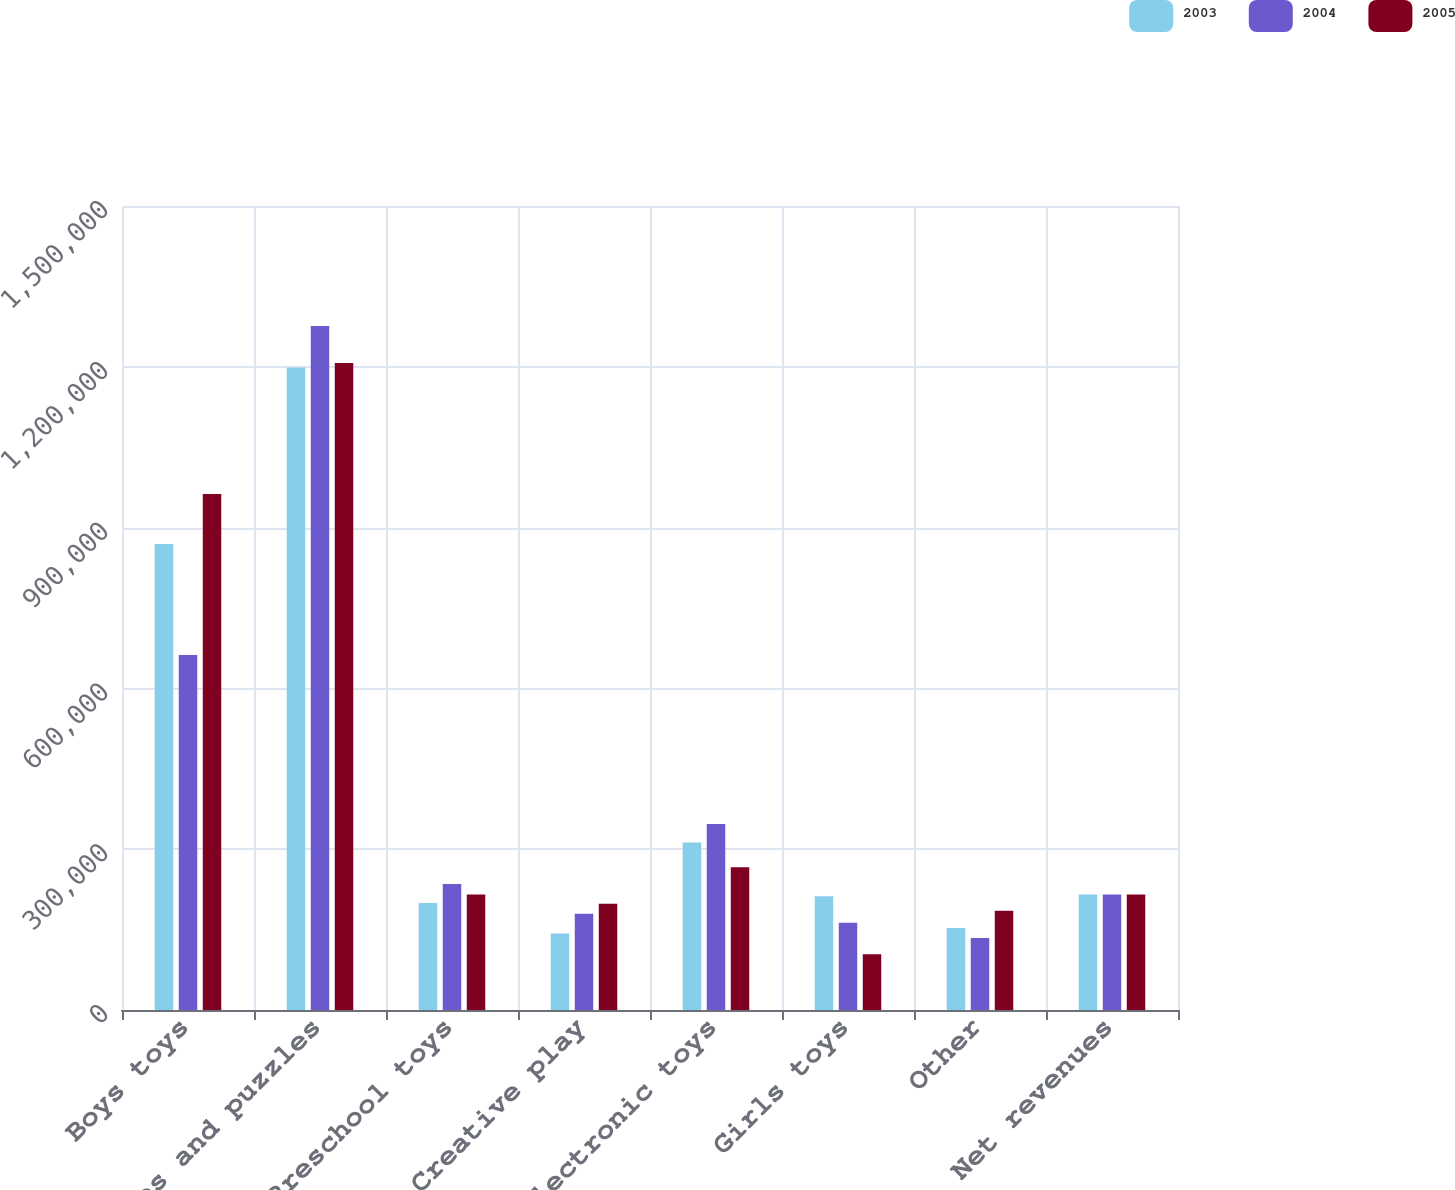Convert chart to OTSL. <chart><loc_0><loc_0><loc_500><loc_500><stacked_bar_chart><ecel><fcel>Boys toys<fcel>Games and puzzles<fcel>Preschool toys<fcel>Creative play<fcel>Electronic toys<fcel>Girls toys<fcel>Other<fcel>Net revenues<nl><fcel>2003<fcel>869300<fcel>1.1988e+06<fcel>199500<fcel>142600<fcel>312600<fcel>212000<fcel>152827<fcel>215500<nl><fcel>2004<fcel>662500<fcel>1.2761e+06<fcel>235100<fcel>179700<fcel>347000<fcel>162800<fcel>134310<fcel>215500<nl><fcel>2005<fcel>962500<fcel>1.2071e+06<fcel>215500<fcel>198100<fcel>266500<fcel>104000<fcel>184957<fcel>215500<nl></chart> 